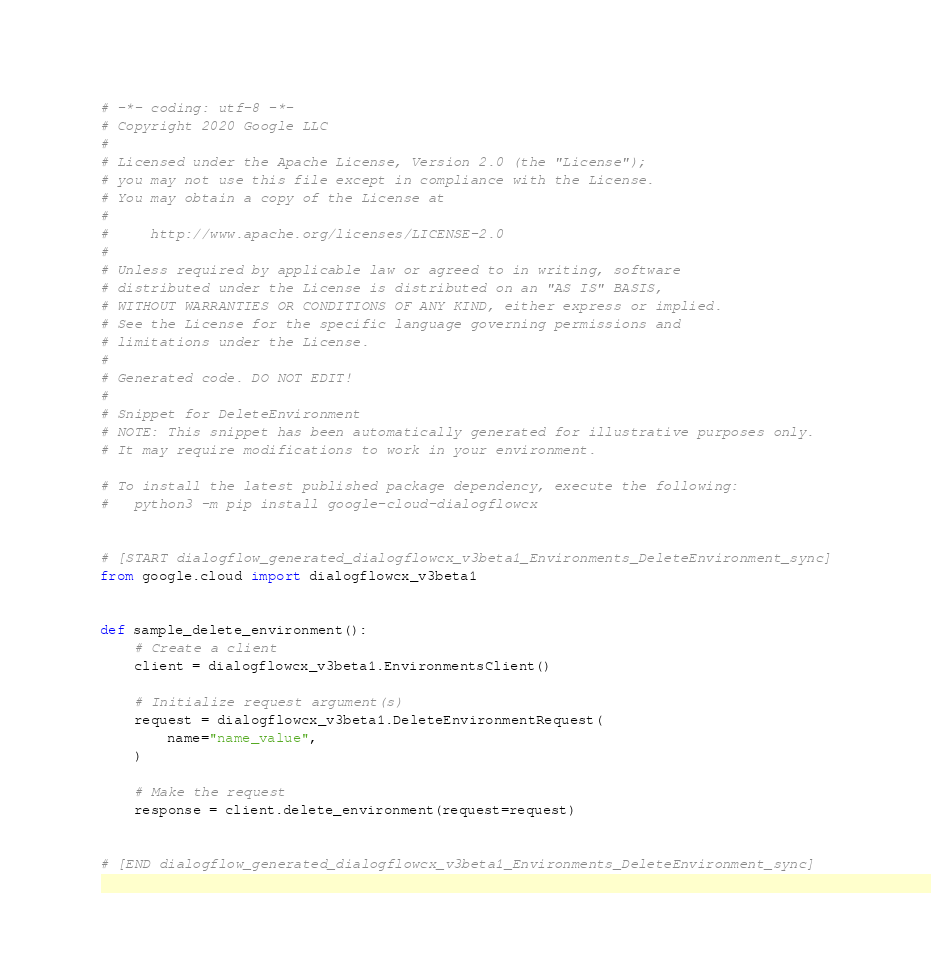Convert code to text. <code><loc_0><loc_0><loc_500><loc_500><_Python_># -*- coding: utf-8 -*-
# Copyright 2020 Google LLC
#
# Licensed under the Apache License, Version 2.0 (the "License");
# you may not use this file except in compliance with the License.
# You may obtain a copy of the License at
#
#     http://www.apache.org/licenses/LICENSE-2.0
#
# Unless required by applicable law or agreed to in writing, software
# distributed under the License is distributed on an "AS IS" BASIS,
# WITHOUT WARRANTIES OR CONDITIONS OF ANY KIND, either express or implied.
# See the License for the specific language governing permissions and
# limitations under the License.
#
# Generated code. DO NOT EDIT!
#
# Snippet for DeleteEnvironment
# NOTE: This snippet has been automatically generated for illustrative purposes only.
# It may require modifications to work in your environment.

# To install the latest published package dependency, execute the following:
#   python3 -m pip install google-cloud-dialogflowcx


# [START dialogflow_generated_dialogflowcx_v3beta1_Environments_DeleteEnvironment_sync]
from google.cloud import dialogflowcx_v3beta1


def sample_delete_environment():
    # Create a client
    client = dialogflowcx_v3beta1.EnvironmentsClient()

    # Initialize request argument(s)
    request = dialogflowcx_v3beta1.DeleteEnvironmentRequest(
        name="name_value",
    )

    # Make the request
    response = client.delete_environment(request=request)


# [END dialogflow_generated_dialogflowcx_v3beta1_Environments_DeleteEnvironment_sync]
</code> 